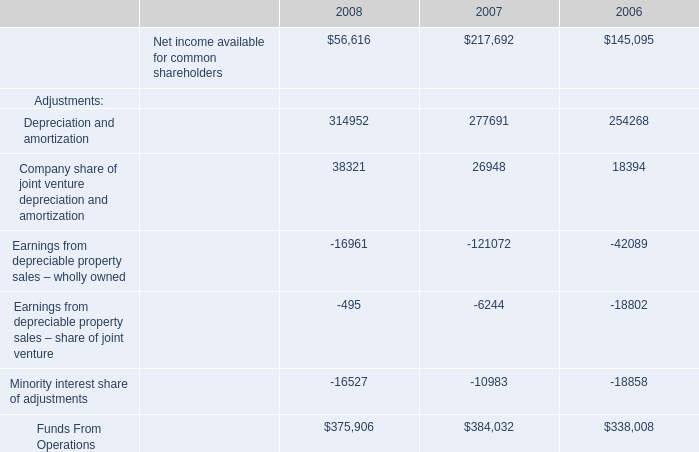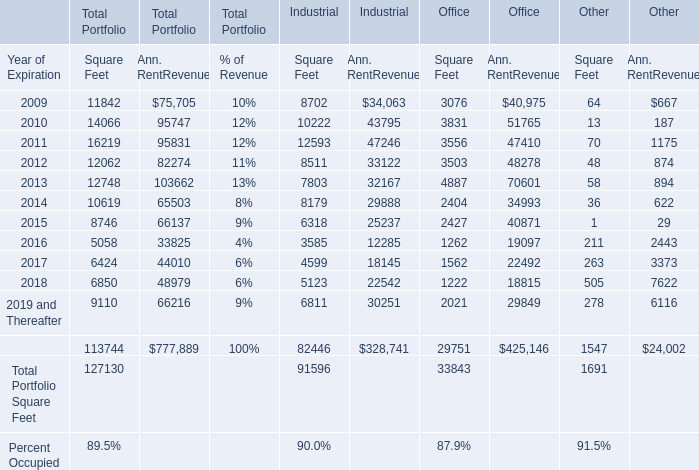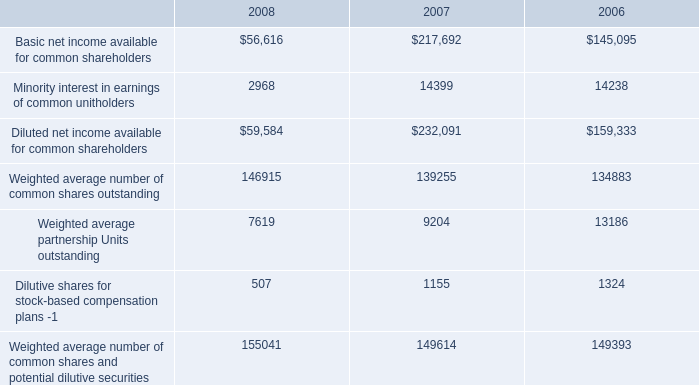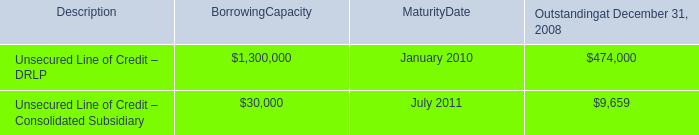what was the percentage improvement in the unbilled receivables on construction contracts from 2007 to 2008 
Computations: ((22.7 - 33.1) / 33.1)
Answer: -0.3142. 